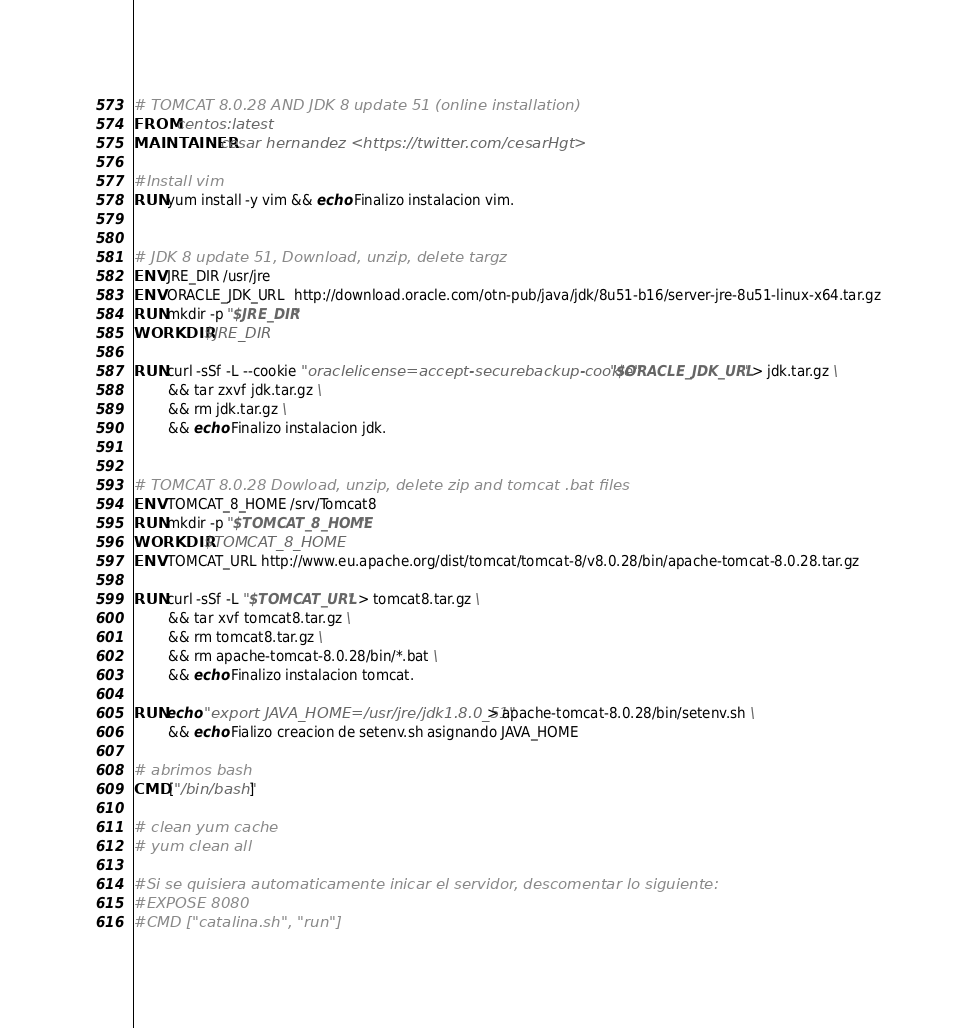Convert code to text. <code><loc_0><loc_0><loc_500><loc_500><_Dockerfile_># TOMCAT 8.0.28 AND JDK 8 update 51 (online installation)
FROM centos:latest
MAINTAINER cesar hernandez <https://twitter.com/cesarHgt>

#Install vim
RUN yum install -y vim && echo Finalizo instalacion vim.


# JDK 8 update 51, Download, unzip, delete targz
ENV JRE_DIR /usr/jre
ENV ORACLE_JDK_URL  http://download.oracle.com/otn-pub/java/jdk/8u51-b16/server-jre-8u51-linux-x64.tar.gz
RUN mkdir -p "$JRE_DIR"
WORKDIR $JRE_DIR

RUN curl -sSf -L --cookie "oraclelicense=accept-securebackup-cookie" "$ORACLE_JDK_URL" > jdk.tar.gz \
        && tar zxvf jdk.tar.gz \
        && rm jdk.tar.gz \
        && echo Finalizo instalacion jdk.


# TOMCAT 8.0.28 Dowload, unzip, delete zip and tomcat .bat files
ENV TOMCAT_8_HOME /srv/Tomcat8
RUN mkdir -p "$TOMCAT_8_HOME"
WORKDIR $TOMCAT_8_HOME
ENV TOMCAT_URL http://www.eu.apache.org/dist/tomcat/tomcat-8/v8.0.28/bin/apache-tomcat-8.0.28.tar.gz

RUN curl -sSf -L "$TOMCAT_URL" > tomcat8.tar.gz \
        && tar xvf tomcat8.tar.gz \
        && rm tomcat8.tar.gz \
        && rm apache-tomcat-8.0.28/bin/*.bat \
        && echo Finalizo instalacion tomcat. 

RUN echo "export JAVA_HOME=/usr/jre/jdk1.8.0_51" > apache-tomcat-8.0.28/bin/setenv.sh \
        && echo Fializo creacion de setenv.sh asignando JAVA_HOME 

# abrimos bash
CMD ["/bin/bash"]

# clean yum cache
# yum clean all

#Si se quisiera automaticamente inicar el servidor, descomentar lo siguiente:
#EXPOSE 8080
#CMD ["catalina.sh", "run"]</code> 